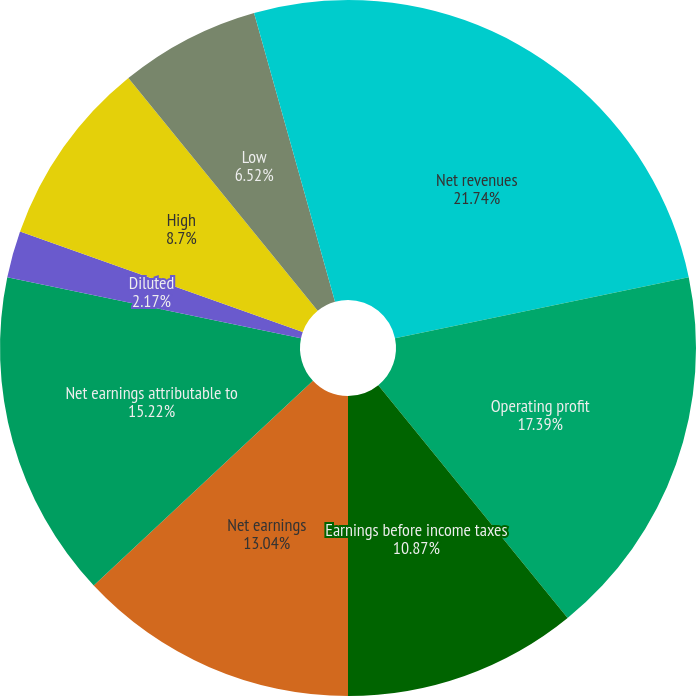Convert chart. <chart><loc_0><loc_0><loc_500><loc_500><pie_chart><fcel>Net revenues<fcel>Operating profit<fcel>Earnings before income taxes<fcel>Net earnings<fcel>Net earnings attributable to<fcel>Basic<fcel>Diluted<fcel>High<fcel>Low<fcel>Cash dividends declared<nl><fcel>21.74%<fcel>17.39%<fcel>10.87%<fcel>13.04%<fcel>15.22%<fcel>0.0%<fcel>2.17%<fcel>8.7%<fcel>6.52%<fcel>4.35%<nl></chart> 